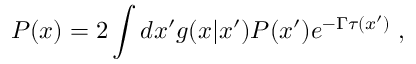Convert formula to latex. <formula><loc_0><loc_0><loc_500><loc_500>P ( x ) = 2 \int d x ^ { \prime } g ( x | x ^ { \prime } ) P ( x ^ { \prime } ) e ^ { - \Gamma \tau ( x ^ { \prime } ) } \, ,</formula> 